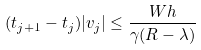<formula> <loc_0><loc_0><loc_500><loc_500>( t _ { j + 1 } - t _ { j } ) | v _ { j } | \leq \frac { W h } { \gamma ( R - \lambda ) }</formula> 